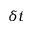Convert formula to latex. <formula><loc_0><loc_0><loc_500><loc_500>\delta t</formula> 